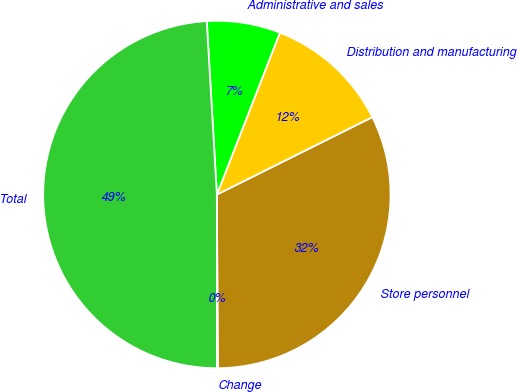<chart> <loc_0><loc_0><loc_500><loc_500><pie_chart><fcel>Store personnel<fcel>Distribution and manufacturing<fcel>Administrative and sales<fcel>Total<fcel>Change<nl><fcel>32.27%<fcel>11.74%<fcel>6.84%<fcel>49.08%<fcel>0.08%<nl></chart> 